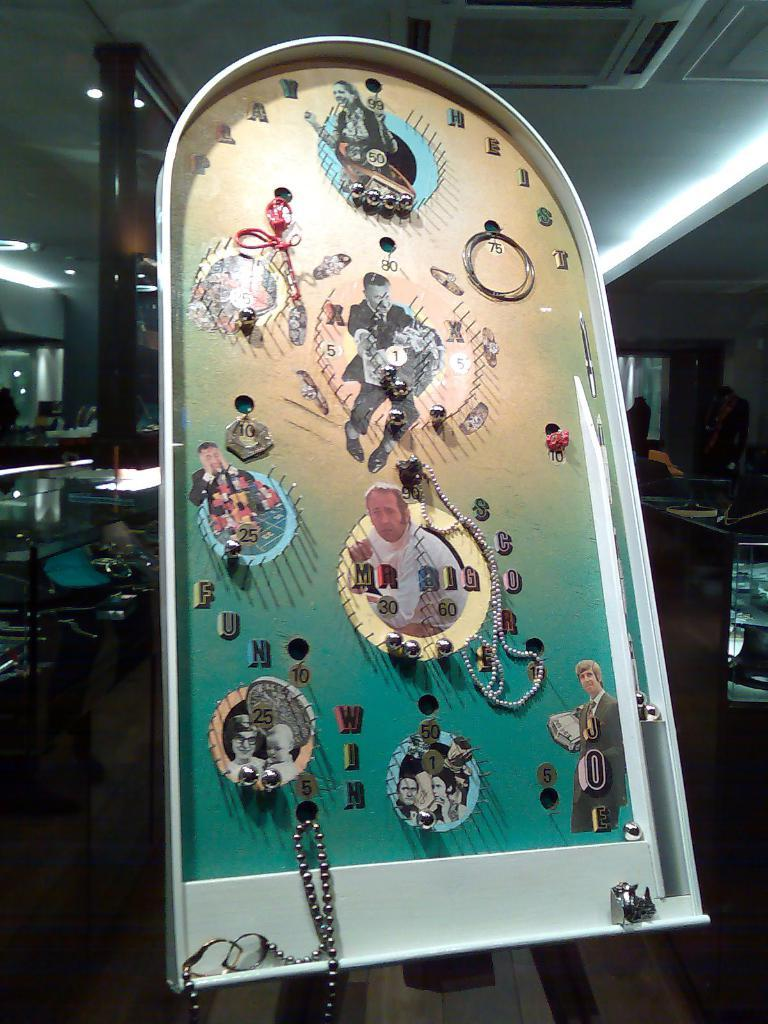What is the main object in the image? There is a board in the image. What can be seen on the board? The board contains photos of different people. Where is the jar of milk placed on the board in the image? There is no jar of milk present on the board in the image. What type of stove is used to cook the cows in the image? There are no cows or stoves present in the image; it only contains a board with photos of different people. 